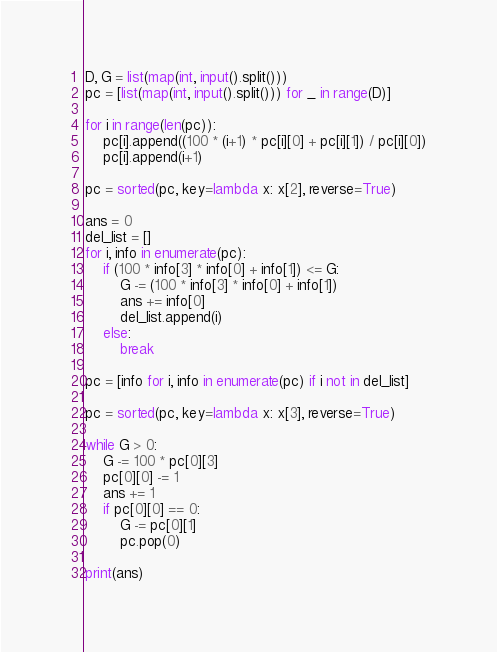Convert code to text. <code><loc_0><loc_0><loc_500><loc_500><_Python_>D, G = list(map(int, input().split()))
pc = [list(map(int, input().split())) for _ in range(D)]

for i in range(len(pc)):
    pc[i].append((100 * (i+1) * pc[i][0] + pc[i][1]) / pc[i][0])
    pc[i].append(i+1)

pc = sorted(pc, key=lambda x: x[2], reverse=True)

ans = 0
del_list = []
for i, info in enumerate(pc):
    if (100 * info[3] * info[0] + info[1]) <= G:
        G -= (100 * info[3] * info[0] + info[1])
        ans += info[0]
        del_list.append(i)
    else:
        break

pc = [info for i, info in enumerate(pc) if i not in del_list]

pc = sorted(pc, key=lambda x: x[3], reverse=True)

while G > 0:
    G -= 100 * pc[0][3]
    pc[0][0] -= 1
    ans += 1
    if pc[0][0] == 0:
        G -= pc[0][1]
        pc.pop(0)

print(ans)</code> 